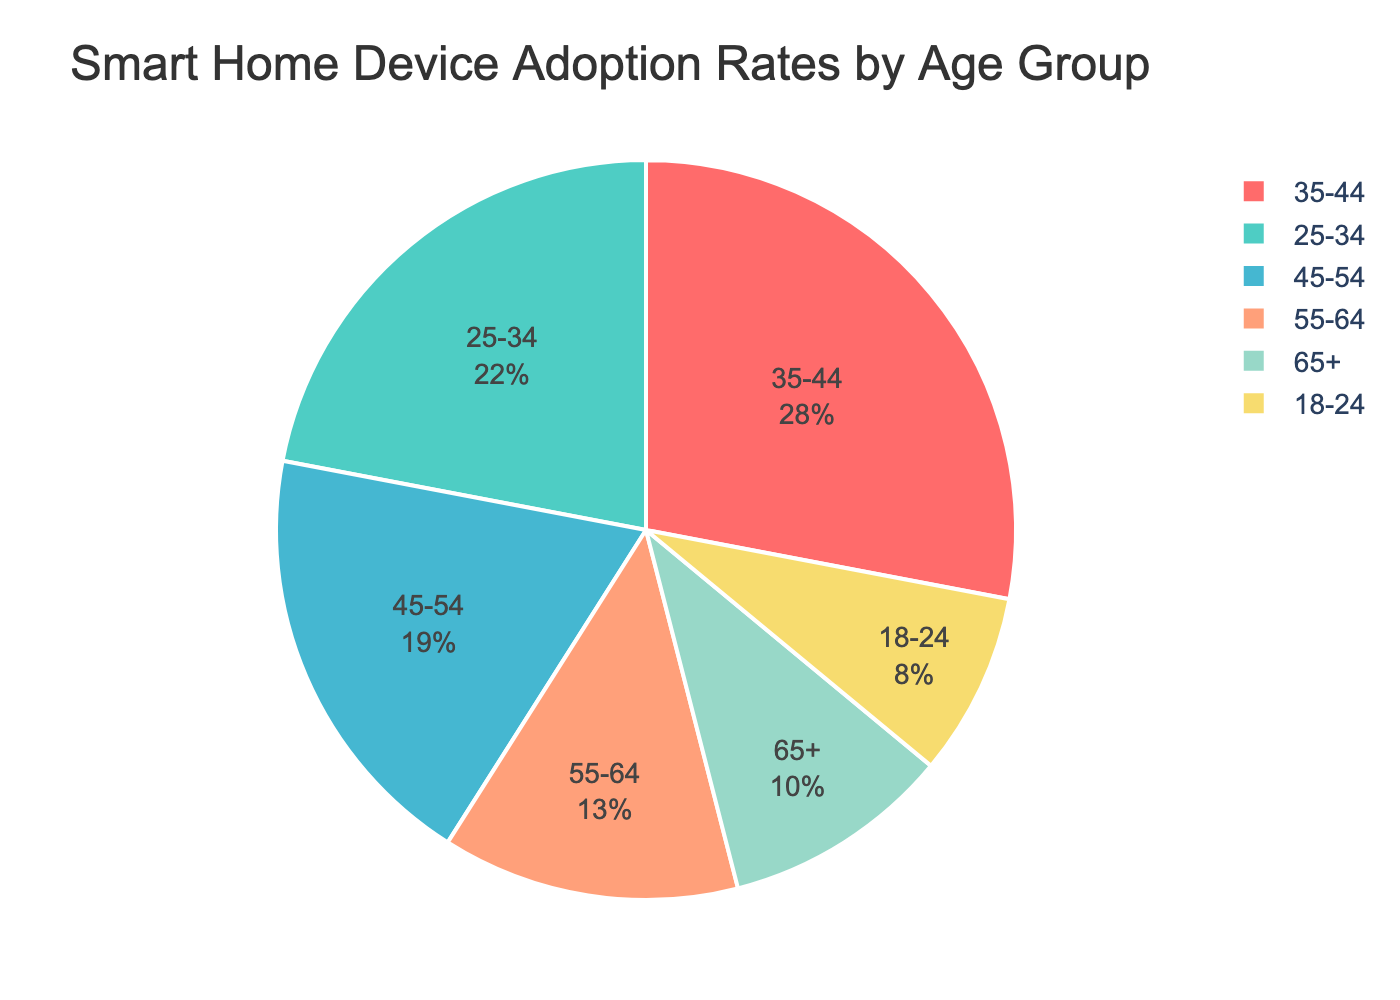Which age group has the highest adoption rate? The chart shows the adoption rates for different age groups. The 35-44 age group has the largest section of the pie chart.
Answer: 35-44 What is the total adoption rate for the 25-34 and 35-44 age groups? Add the adoption rates of the 25-34 (22) and 35-44 (28) age groups. 22 + 28 = 50
Answer: 50 Which age group has a higher adoption rate, 55-64 or 65+? Compare the two segments of the pie chart for the 55-64 and 65+ age groups. The 55-64 age group is larger.
Answer: 55-64 What percentage of the total adoption rate does the 18-24 age group represent? The pie chart shows percentages. Identify the section for the 18-24 age group, which has 8%.
Answer: 8% Is the adoption rate of the 45-54 age group greater than that of the 55-64 age group? Compare the two ages groups on the pie chart; visually identify that the 45-54 segment is larger than the 55-64 one.
Answer: Yes What is the difference in adoption rate between the 45-54 and 65+ age groups? Subtract the adoption rate of the 65+ group (10) from the 45-54 group (19). 19 - 10 = 9
Answer: 9 If you sum the adoption rates of the youngest and oldest age groups (18-24 and 65+), what is the result? Add the adoption rates of the 18-24 age group (8) and the 65+ age group (10). 8 + 10 = 18
Answer: 18 Which color represents the 25-34 age group in the chart? Look at the legend and match the color associated with the 25-34 age group, which is green.
Answer: Green What's the average adoption rate of the age groups from 45-64? Calculate the average by adding the adoption rates of the 45-54 (19) and 55-64 (13) groups, then divide by 2. (19 + 13) / 2 = 16
Answer: 16 Is the adoption rate for the 35-44 age group equal to the combined rate of the 18-24 and 65+ age groups? Compare the adoption rate of the 35-44 group (28) to the sum of 18-24 and 65+ groups (8 + 10 = 18). No, they are not equal.
Answer: No 